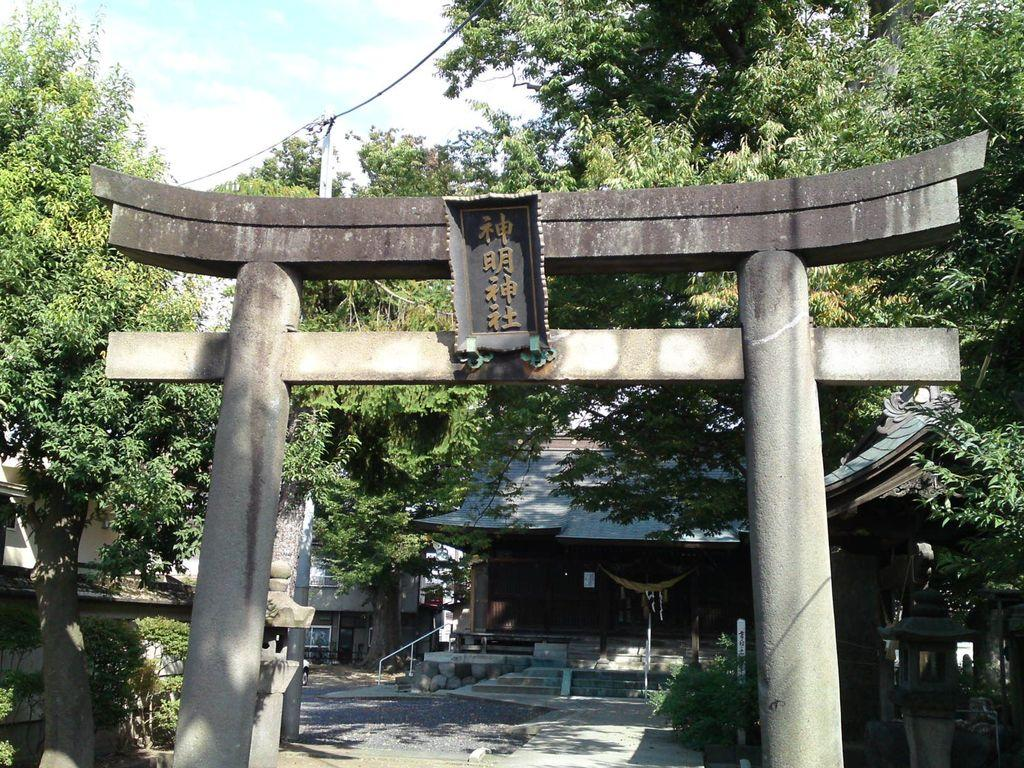What structure is located in the middle of the image? There is an arch in the middle of the image. What is located at the back of the image? There is a house at the back of the image. What type of vegetation is present in the image? There are trees in the image. What is visible at the top of the image? The sky is visible at the top of the image. What type of butter can be seen melting on the trees in the image? There is no butter present in the image; it features an arch, a house, trees, and the sky. How low is the mist in the image? There is no mist present in the image; it is a clear sky visible at the top of the image. 